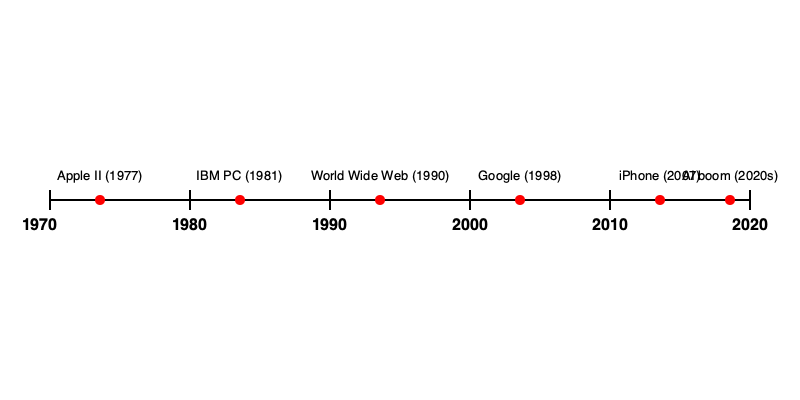Based on the timeline, which technological milestone occurred closest to the midpoint between the introduction of the Apple II and the launch of the iPhone, and how many years after the Apple II did this event take place? To solve this problem, we need to follow these steps:

1. Identify the years for the Apple II introduction and iPhone launch:
   - Apple II: 1977
   - iPhone: 2007

2. Calculate the midpoint between these two events:
   - Time span: 2007 - 1977 = 30 years
   - Midpoint: 1977 + (30 / 2) = 1977 + 15 = 1992

3. Identify the event closest to 1992 on the timeline:
   - The World Wide Web (1990) is the closest event to 1992

4. Calculate the number of years between the Apple II and the World Wide Web:
   - 1990 - 1977 = 13 years

Therefore, the World Wide Web, introduced in 1990, is the technological milestone closest to the midpoint between the Apple II and the iPhone. It occurred 13 years after the introduction of the Apple II.
Answer: World Wide Web, 13 years 